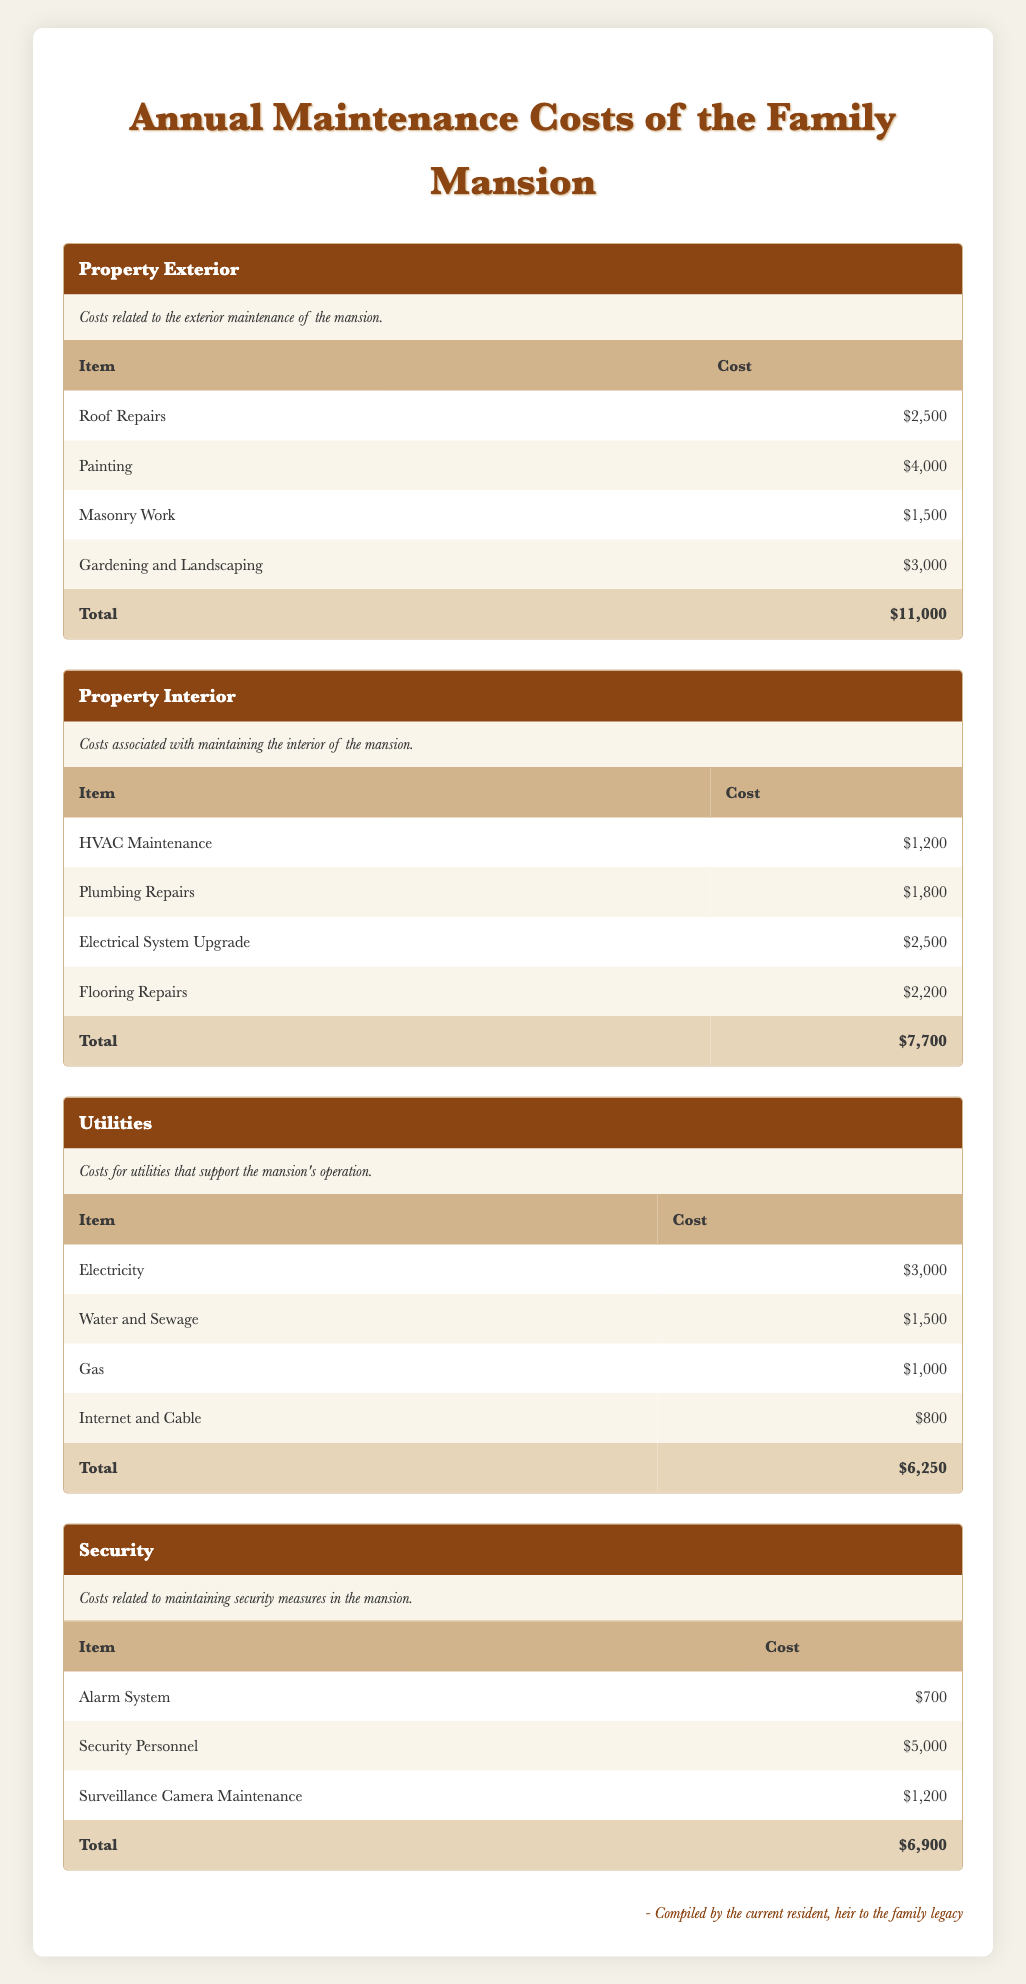What is the total annual maintenance cost for the mansion? To find the total annual maintenance cost, we need to sum the total costs from each category: Property Exterior ($11,000) + Property Interior ($7,700) + Utilities ($6,250) + Security ($6,900). Adding these gives us $11,000 + $7,700 + $6,250 + $6,900 = $31,850.
Answer: 31,850 Which category has the highest total maintenance cost? Comparing the total costs of each category: Property Exterior ($11,000), Property Interior ($7,700), Utilities ($6,250), and Security ($6,900), Property Exterior has the highest total at $11,000.
Answer: Property Exterior Are the costs for Gardening and Landscaping higher than those for Masonry Work? The cost for Gardening and Landscaping is $3,000, while the cost for Masonry Work is $1,500. Since $3,000 is greater than $1,500, the statement is true.
Answer: Yes What is the average cost of the expenses listed under Utilities? The expenses under Utilities are: Electricity ($3,000), Water and Sewage ($1,500), Gas ($1,000), and Internet and Cable ($800). To find the average, we sum these values: $3,000 + $1,500 + $1,000 + $800 = $6,300. There are 4 items, so we divide: $6,300 / 4 = $1,575.
Answer: 1,575 Is the cost for Electrical System Upgrade greater than the total cost for Alarm System and Surveillance Camera Maintenance combined? The cost for the Electrical System Upgrade is $2,500. The total of the Alarm System ($700) and Surveillance Camera Maintenance ($1,200) is $700 + $1,200 = $1,900. Since $2,500 is greater than $1,900, the statement is true.
Answer: Yes What is the difference between the total costs of Property Exterior and Property Interior? The total cost for Property Exterior is $11,000 and for Property Interior is $7,700. To find the difference, subtract $7,700 from $11,000: $11,000 - $7,700 = $3,300.
Answer: 3,300 How much do the Security Personnel alone cost? The cost for Security Personnel is listed directly in the table as $5,000. Therefore, the answer is straightforward.
Answer: 5,000 If we sum the costs for all expenses under Property Interior, what is the total? The costs for Property Interior include: HVAC Maintenance ($1,200), Plumbing Repairs ($1,800), Electrical System Upgrade ($2,500), and Flooring Repairs ($2,200). Adding these together gives $1,200 + $1,800 + $2,500 + $2,200 = $7,700.
Answer: 7,700 